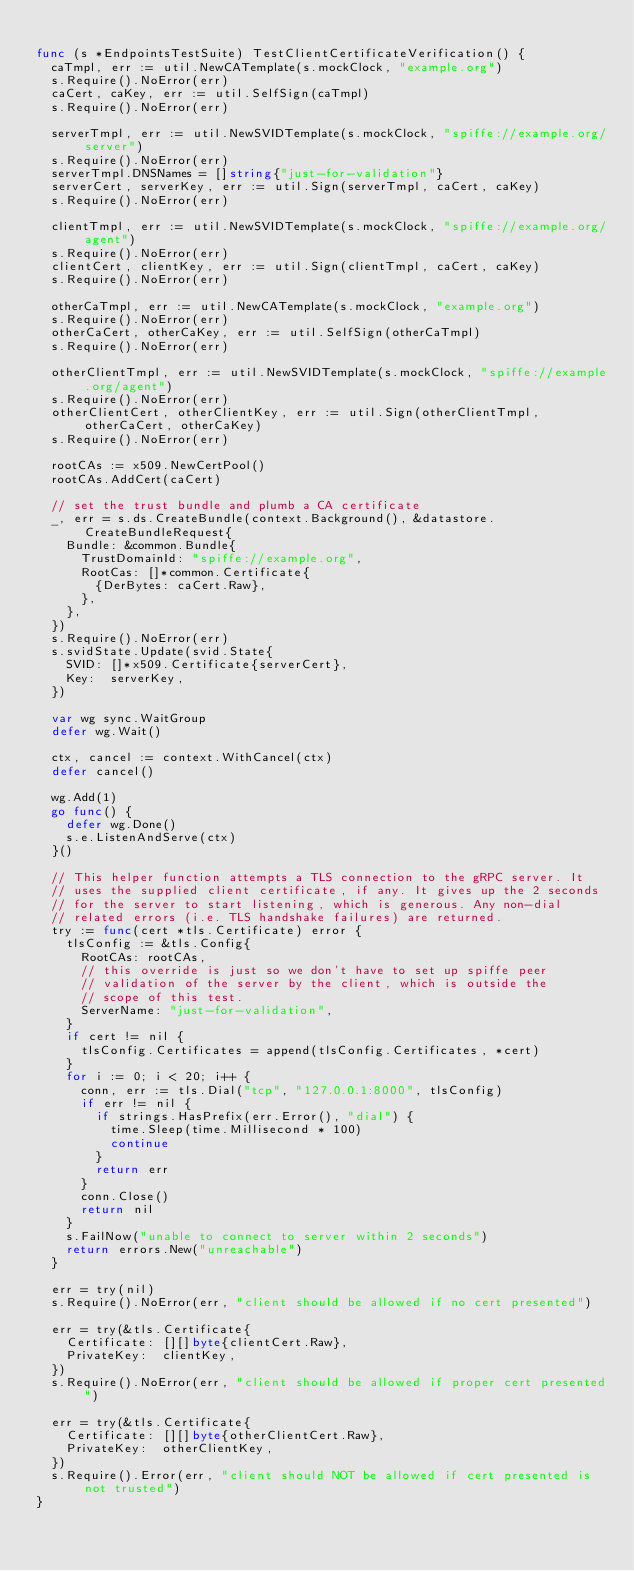<code> <loc_0><loc_0><loc_500><loc_500><_Go_>
func (s *EndpointsTestSuite) TestClientCertificateVerification() {
	caTmpl, err := util.NewCATemplate(s.mockClock, "example.org")
	s.Require().NoError(err)
	caCert, caKey, err := util.SelfSign(caTmpl)
	s.Require().NoError(err)

	serverTmpl, err := util.NewSVIDTemplate(s.mockClock, "spiffe://example.org/server")
	s.Require().NoError(err)
	serverTmpl.DNSNames = []string{"just-for-validation"}
	serverCert, serverKey, err := util.Sign(serverTmpl, caCert, caKey)
	s.Require().NoError(err)

	clientTmpl, err := util.NewSVIDTemplate(s.mockClock, "spiffe://example.org/agent")
	s.Require().NoError(err)
	clientCert, clientKey, err := util.Sign(clientTmpl, caCert, caKey)
	s.Require().NoError(err)

	otherCaTmpl, err := util.NewCATemplate(s.mockClock, "example.org")
	s.Require().NoError(err)
	otherCaCert, otherCaKey, err := util.SelfSign(otherCaTmpl)
	s.Require().NoError(err)

	otherClientTmpl, err := util.NewSVIDTemplate(s.mockClock, "spiffe://example.org/agent")
	s.Require().NoError(err)
	otherClientCert, otherClientKey, err := util.Sign(otherClientTmpl, otherCaCert, otherCaKey)
	s.Require().NoError(err)

	rootCAs := x509.NewCertPool()
	rootCAs.AddCert(caCert)

	// set the trust bundle and plumb a CA certificate
	_, err = s.ds.CreateBundle(context.Background(), &datastore.CreateBundleRequest{
		Bundle: &common.Bundle{
			TrustDomainId: "spiffe://example.org",
			RootCas: []*common.Certificate{
				{DerBytes: caCert.Raw},
			},
		},
	})
	s.Require().NoError(err)
	s.svidState.Update(svid.State{
		SVID: []*x509.Certificate{serverCert},
		Key:  serverKey,
	})

	var wg sync.WaitGroup
	defer wg.Wait()

	ctx, cancel := context.WithCancel(ctx)
	defer cancel()

	wg.Add(1)
	go func() {
		defer wg.Done()
		s.e.ListenAndServe(ctx)
	}()

	// This helper function attempts a TLS connection to the gRPC server. It
	// uses the supplied client certificate, if any. It gives up the 2 seconds
	// for the server to start listening, which is generous. Any non-dial
	// related errors (i.e. TLS handshake failures) are returned.
	try := func(cert *tls.Certificate) error {
		tlsConfig := &tls.Config{
			RootCAs: rootCAs,
			// this override is just so we don't have to set up spiffe peer
			// validation of the server by the client, which is outside the
			// scope of this test.
			ServerName: "just-for-validation",
		}
		if cert != nil {
			tlsConfig.Certificates = append(tlsConfig.Certificates, *cert)
		}
		for i := 0; i < 20; i++ {
			conn, err := tls.Dial("tcp", "127.0.0.1:8000", tlsConfig)
			if err != nil {
				if strings.HasPrefix(err.Error(), "dial") {
					time.Sleep(time.Millisecond * 100)
					continue
				}
				return err
			}
			conn.Close()
			return nil
		}
		s.FailNow("unable to connect to server within 2 seconds")
		return errors.New("unreachable")
	}

	err = try(nil)
	s.Require().NoError(err, "client should be allowed if no cert presented")

	err = try(&tls.Certificate{
		Certificate: [][]byte{clientCert.Raw},
		PrivateKey:  clientKey,
	})
	s.Require().NoError(err, "client should be allowed if proper cert presented")

	err = try(&tls.Certificate{
		Certificate: [][]byte{otherClientCert.Raw},
		PrivateKey:  otherClientKey,
	})
	s.Require().Error(err, "client should NOT be allowed if cert presented is not trusted")
}
</code> 